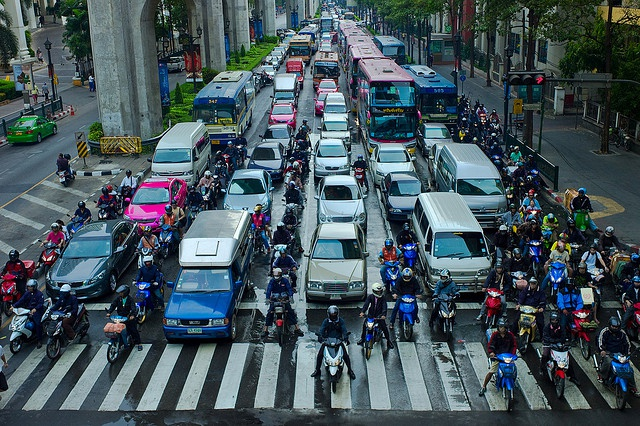Describe the objects in this image and their specific colors. I can see motorcycle in darkgreen, black, gray, blue, and navy tones, people in darkgreen, black, gray, blue, and navy tones, car in darkgreen, black, darkgray, gray, and blue tones, truck in darkgreen, black, darkgray, lightblue, and gray tones, and car in darkgreen, black, blue, teal, and darkgray tones in this image. 